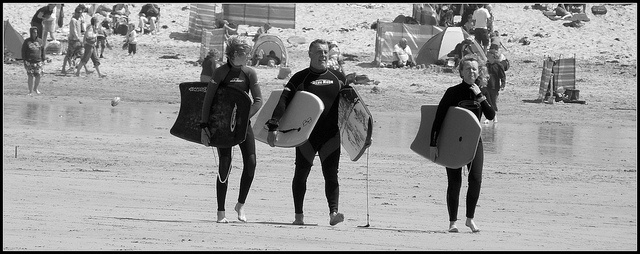Describe the objects in this image and their specific colors. I can see people in black, gray, darkgray, and lightgray tones, people in black, gray, darkgray, and lightgray tones, people in black, gray, darkgray, and lightgray tones, surfboard in black, gray, darkgray, and lightgray tones, and surfboard in black, lightgray, and darkgray tones in this image. 